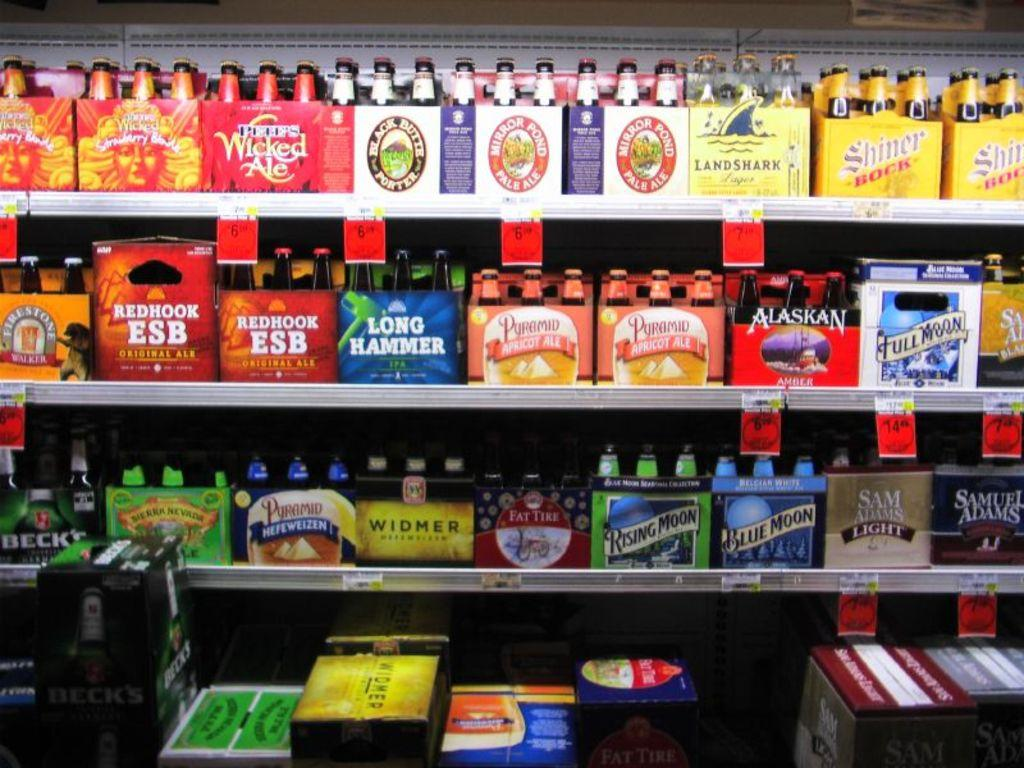<image>
Relay a brief, clear account of the picture shown. Various six packs of beer including Long Hammer and Shiner Bock. 